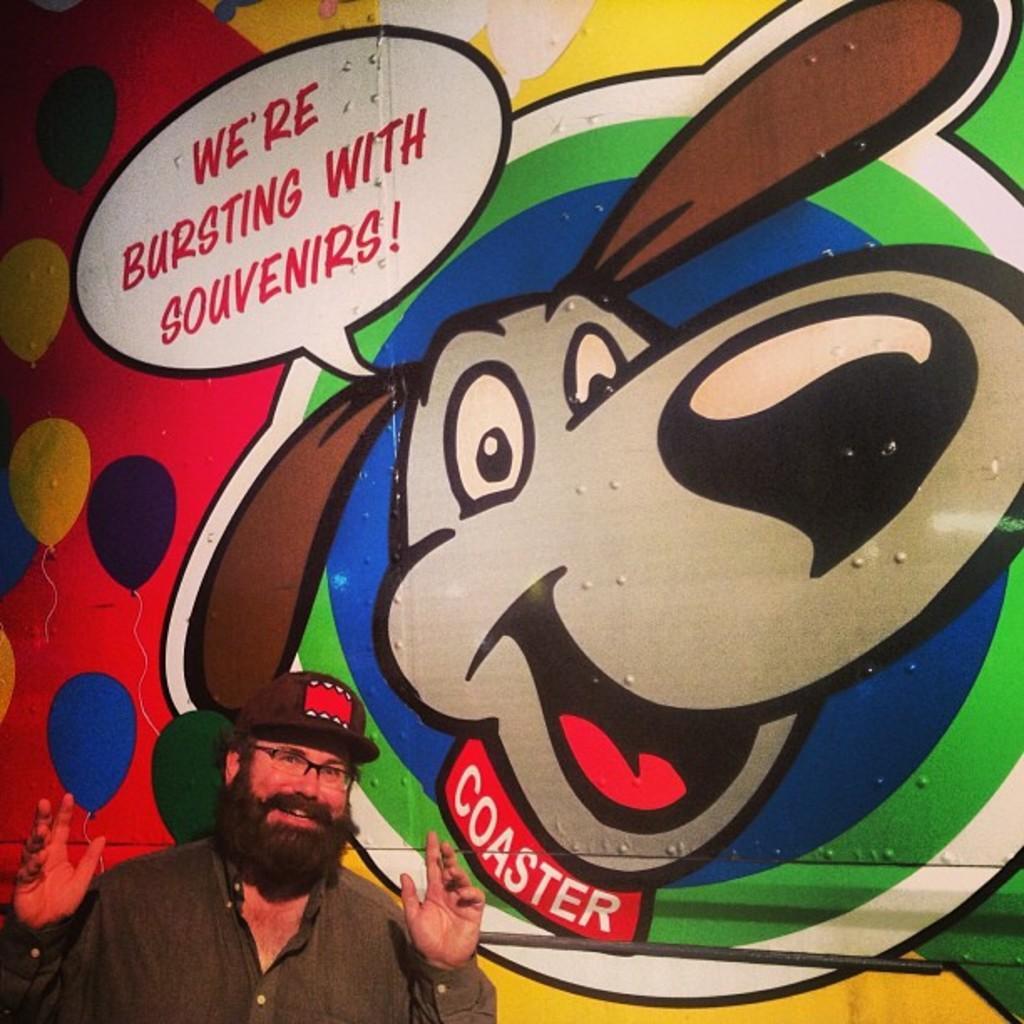How would you summarize this image in a sentence or two? In this image I can see a person wearing hat is standing. In the background I can see a huge wall and a colorful painting on the wall. 